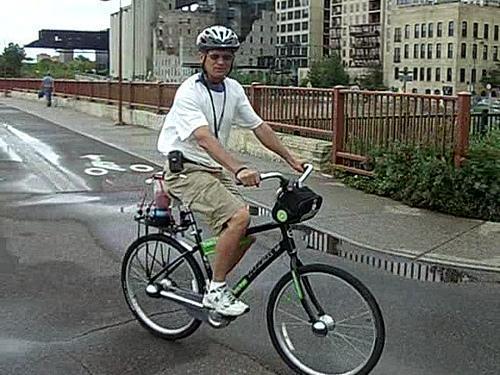What is above the bicycle?
Answer the question by selecting the correct answer among the 4 following choices.
Options: Baby, old woman, man, cat. Man. 